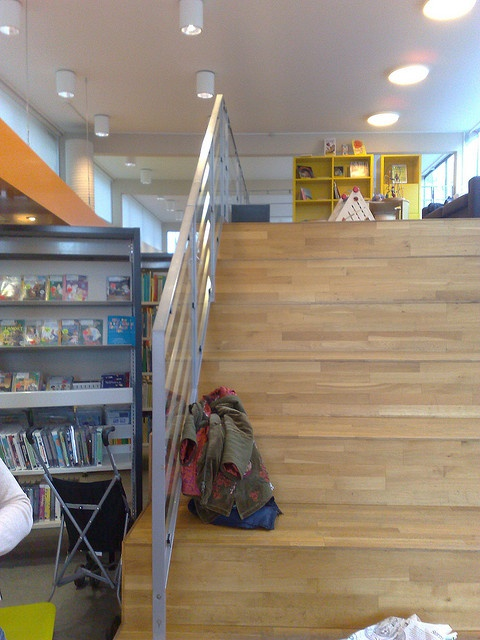Describe the objects in this image and their specific colors. I can see book in darkgray, gray, black, and navy tones, people in darkgray and lavender tones, book in darkgray, teal, gray, and blue tones, book in darkgray and gray tones, and book in darkgray, gray, and tan tones in this image. 